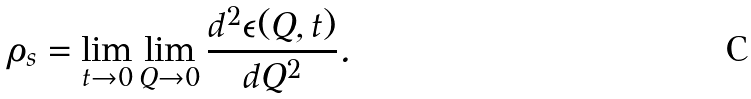<formula> <loc_0><loc_0><loc_500><loc_500>\rho _ { s } = \lim _ { t \rightarrow 0 } \lim _ { Q \rightarrow 0 } \frac { d ^ { 2 } \epsilon ( Q , t ) } { d Q ^ { 2 } } .</formula> 